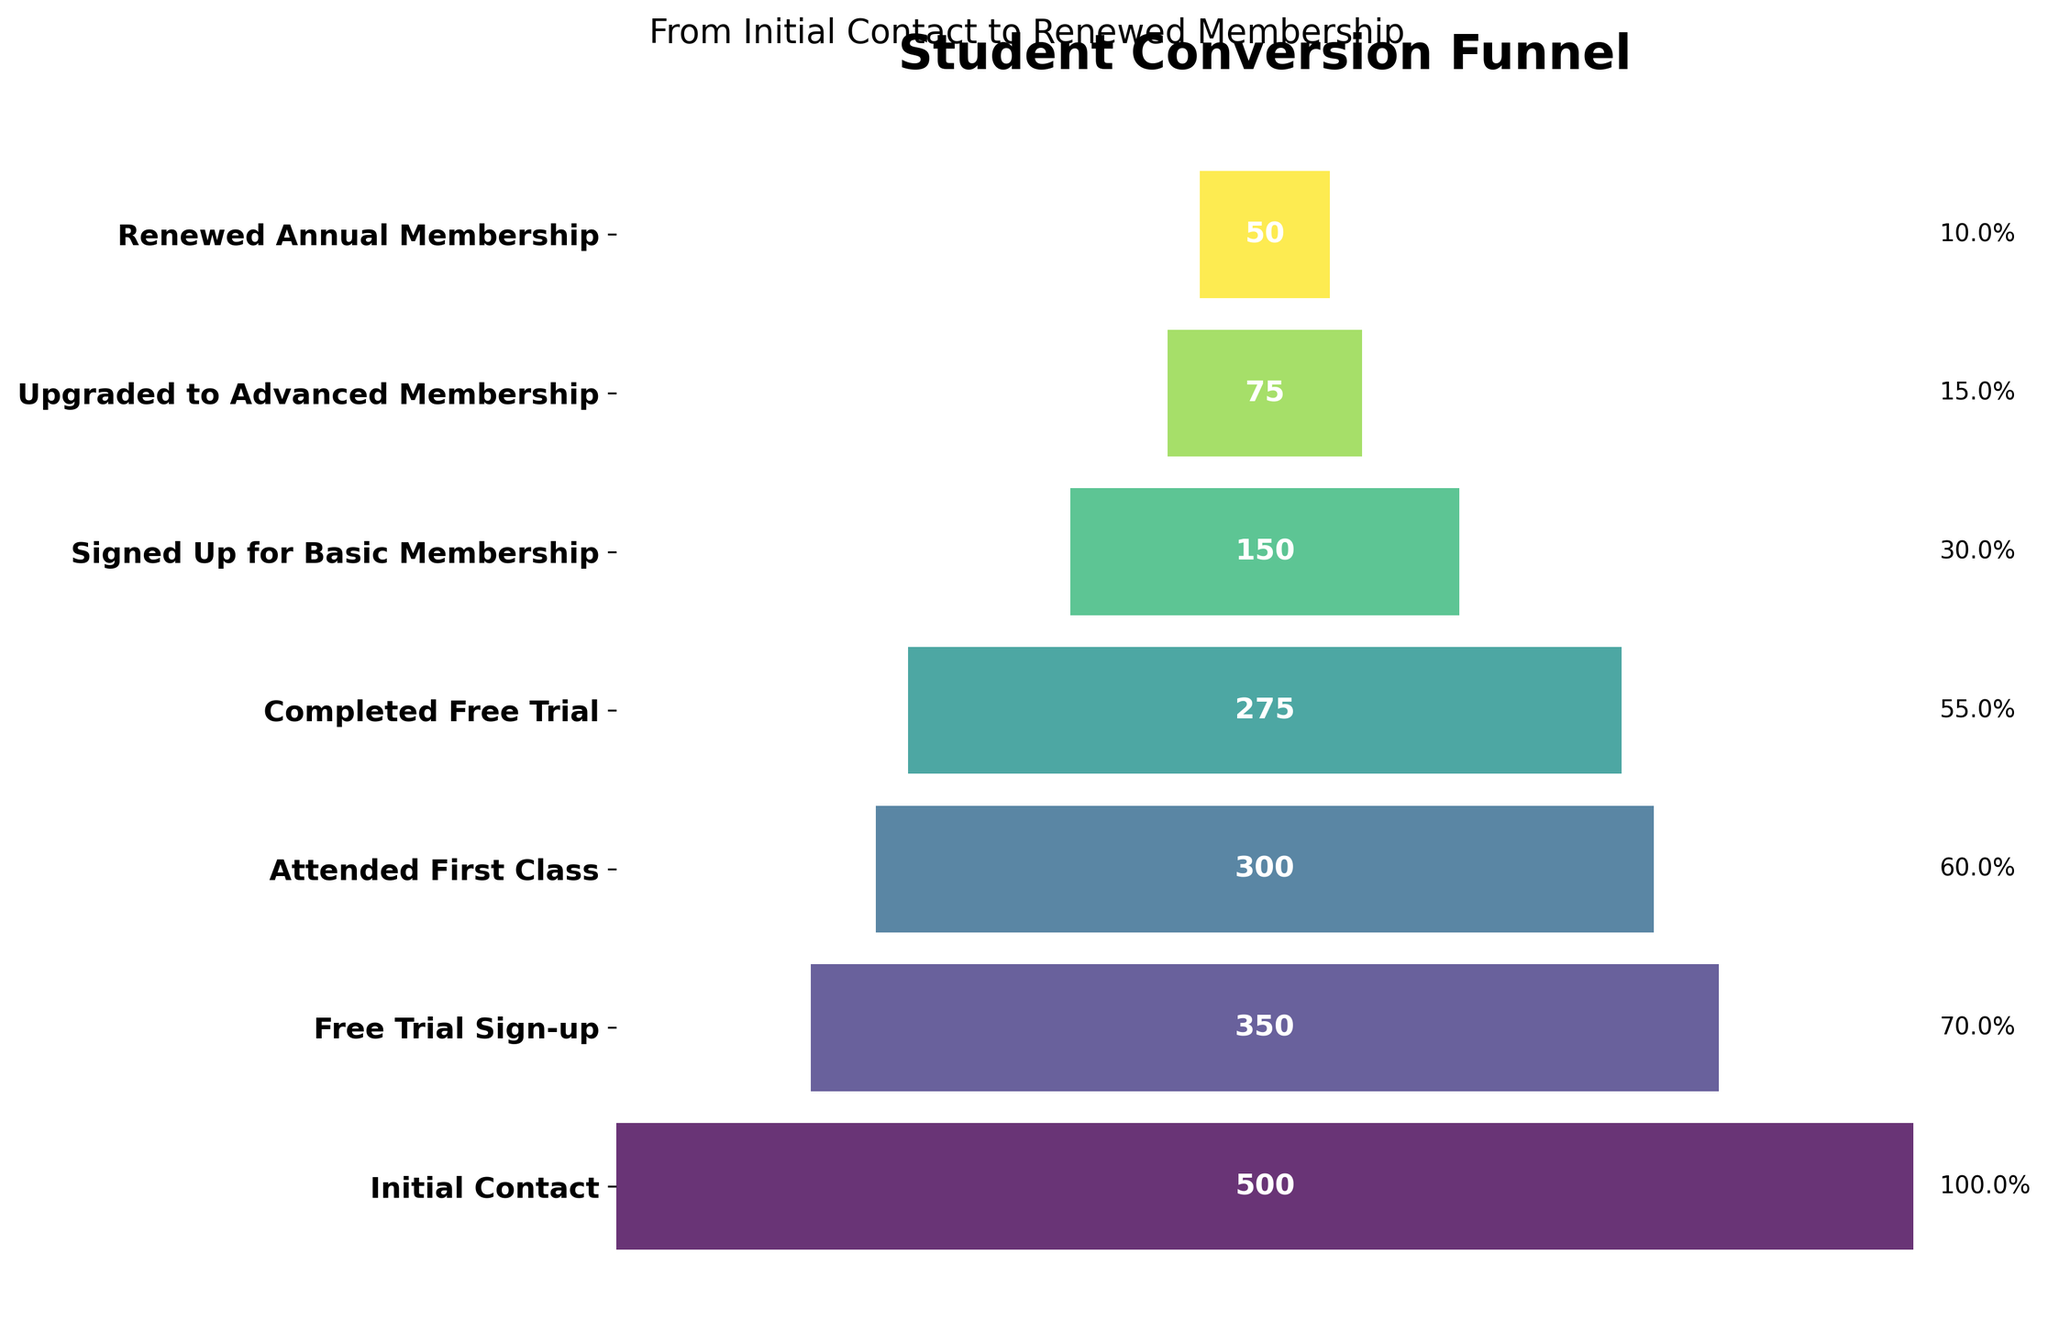How many stages are there in the funnel chart? The stages are represented on the y-axis of the funnel chart. Counting them from top to bottom, there are 7 stages: Initial Contact, Free Trial Sign-up, Attended First Class, Completed Free Trial, Signed Up for Basic Membership, Upgraded to Advanced Membership, and Renewed Annual Membership.
Answer: 7 What is the title of the funnel chart? The title of the funnel chart is displayed at the top of the figure. It reads "Student Conversion Funnel".
Answer: Student Conversion Funnel How many students signed up for basic membership after completing the free trial? According to the funnel chart, the number of students at each stage is indicated within the bars. For the "Signed Up for Basic Membership" stage, the number displayed is 150.
Answer: 150 What percentage of students from the Initial Contact stage renewed their annual membership? To calculate the percentage, take the number of students who renewed their annual membership (50) and divide it by the number of students at the initial contact stage (500), then multiply by 100. \( \left( \frac{50}{500} \right) \times 100 = 10 \% \)
Answer: 10% Which stage has the biggest drop in student numbers compared to the previous stage? To identify this, we need to find the difference in student numbers between each successive stage and compare them. The largest drop is between "Completed Free Trial" (275 students) and "Signed Up for Basic Membership" (150 students), which is 275 - 150 = 125.
Answer: Completed Free Trial to Signed Up for Basic Membership How many students advanced from basic to advanced membership? The funnel chart shows the number of students at each stage. The "Upgraded to Advanced Membership" stage displays the number 75, which represents students advancing from basic to advanced membership.
Answer: 75 What is the conversion rate from the "Free Trial Sign-up" stage to the "Attended First Class" stage? To get the conversion rate, divide the number of students who attended the first class (300) by the number of free trial sign-ups (350) and multiply by 100. \( \left( \frac{300}{350} \right) \times 100 \approx 85.7 \% \)
Answer: 85.7% Of the students who signed up for the free trial, what fraction eventually renewed their annual membership? First, identify the number of students who signed up for the free trial (350) and those who renewed the annual membership (50). The fraction is \( \frac{50}{350} \). Simplifying this, \( \frac{50}{350} = \frac{1}{7} \).
Answer: 1/7 Compare the number of students who attended the first class to those who signed up for the free trial. Which one has more, and by how much? From the chart, "Attended First Class" has 300 students, and "Free Trial Sign-up" has 350 students. The difference is 350 - 300 = 50 students. The Free Trial Sign-up stage has 50 more students.
Answer: Free Trial Sign-up by 50 How does the color change as you move down the stages? As observed visually, the funnel chart uses a color gradient, transitioning from lighter to darker shades as it moves down the stages, indicating the progression through the stages.
Answer: From lighter to darker 